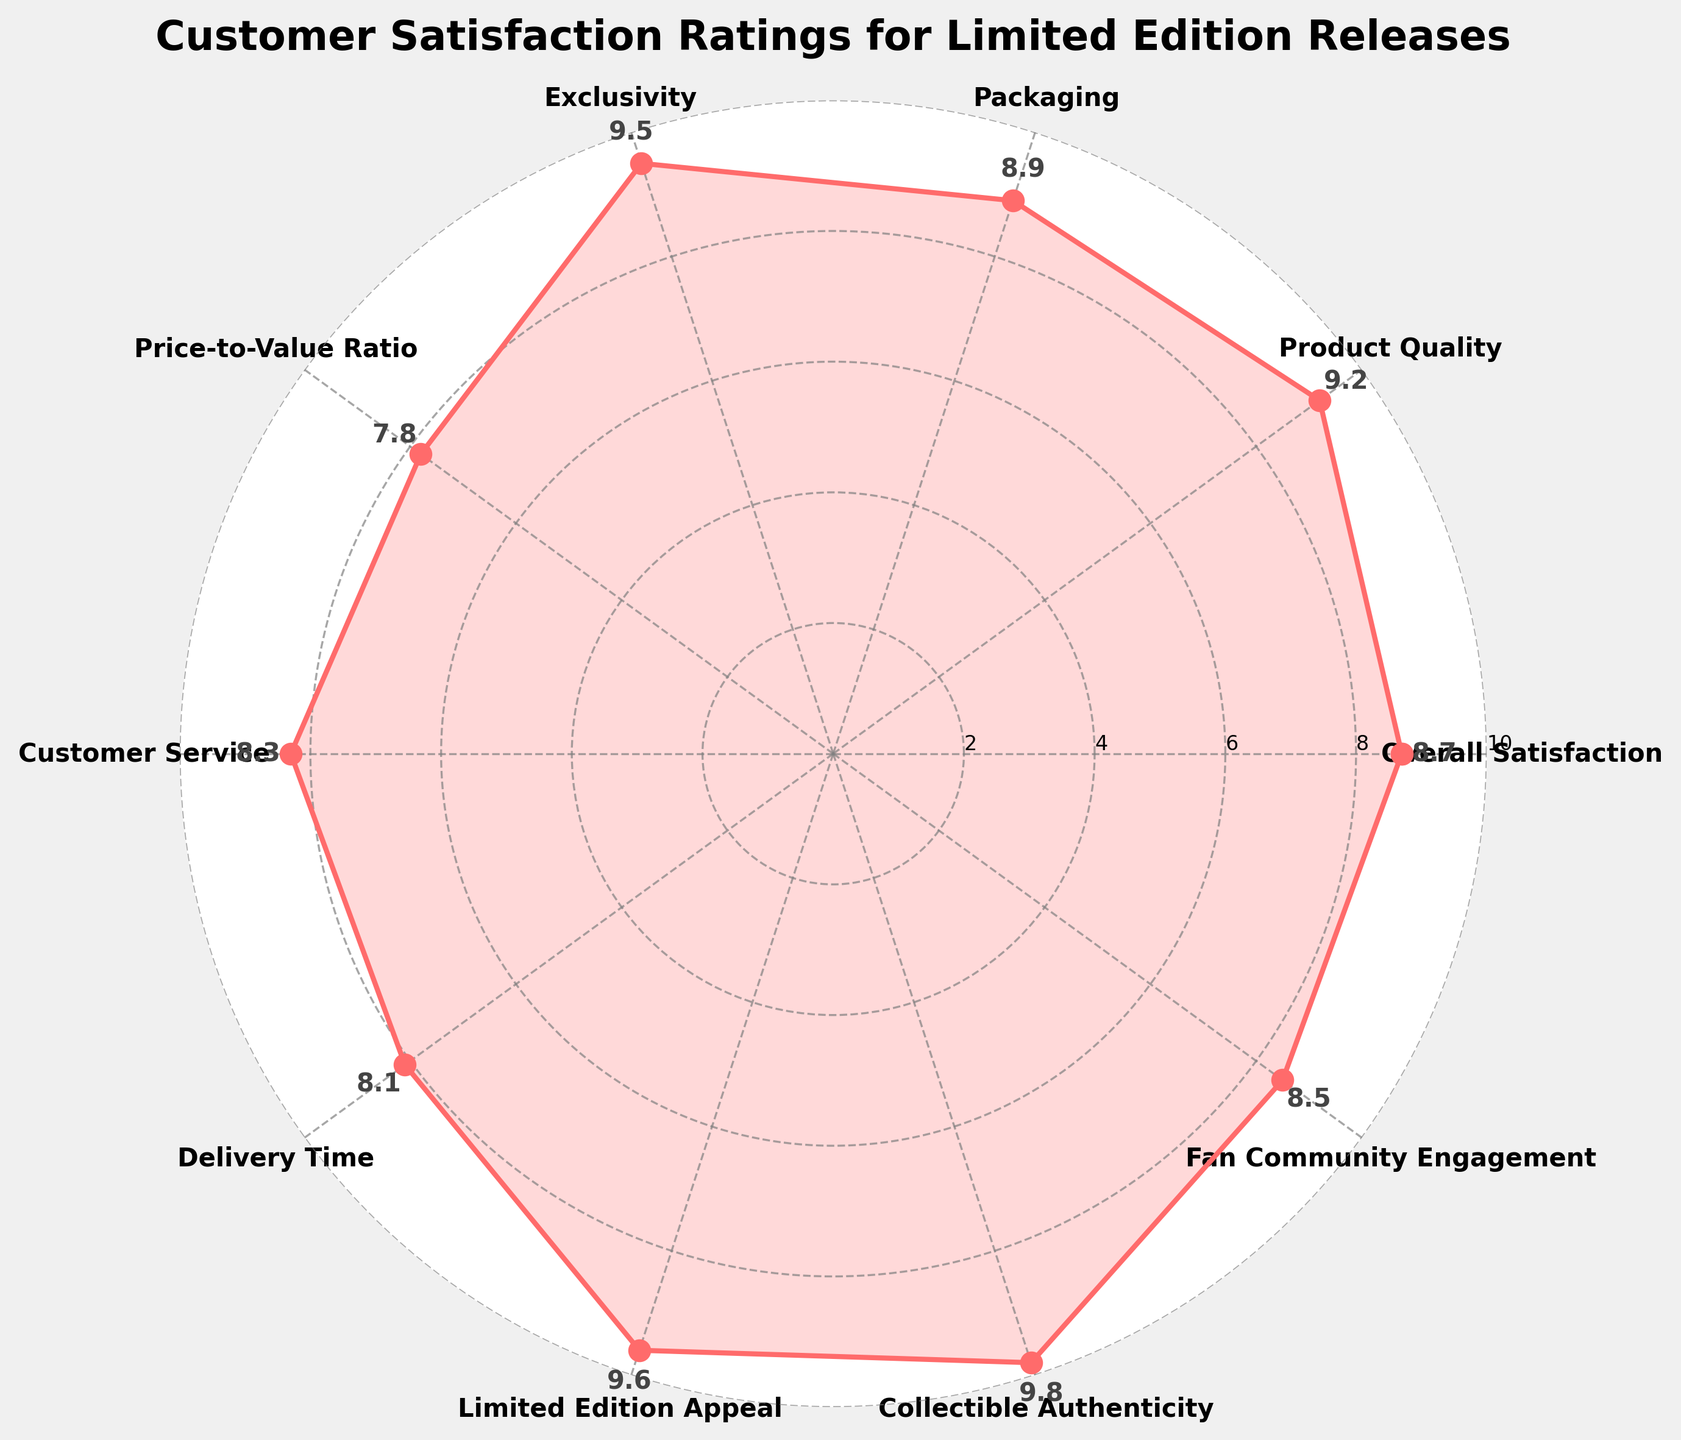What's the highest satisfaction rating shown in the figure? Identify the highest value among the ratings. The highest rating in the figure is 9.8 for "Collectible Authenticity".
Answer: 9.8 Which category has the lowest satisfaction rating? Compare all the satisfaction ratings and identify the category with the lowest value. "Price-to-Value Ratio" is the lowest with a rating of 7.8.
Answer: Price-to-Value Ratio What is the overall title of the figure? The title is given at the top of the figure, which summarizes the chart's content. The title is "Customer Satisfaction Ratings for Limited Edition Releases".
Answer: Customer Satisfaction Ratings for Limited Edition Releases How many categories are rated in the figure? Count the number of distinct points or categories along the polar plot. There are 10 categories rated.
Answer: 10 Which categories have ratings above 9? Examine the figure and list all categories with values above 9. These categories are "Product Quality", "Exclusivity", "Limited Edition Appeal", and "Collectible Authenticity".
Answer: Product Quality, Exclusivity, Limited Edition Appeal, Collectible Authenticity What is the average rating for all categories? Calculate the sum of all ratings and divide by the number of categories. Sum = 8.7 + 9.2 + 8.9 + 9.5 + 7.8 + 8.3 + 8.1 + 9.6 + 9.8 + 8.5, which is 88.4. Average = 88.4 / 10 = 8.84
Answer: 8.84 Is the satisfaction rating for "Delivery Time" above or below 9? Directly check the value next to "Delivery Time". The rating is 8.1, which is below 9.
Answer: Below How many categories have a rating below the average rating of all categories? First, find the average rating for all categories, which is 8.84. Then, count how many categories have a rating below 8.84. Those are "Overall Satisfaction", "Packaging", "Price-to-Value Ratio", "Customer Service", "Delivery Time", and "Fan Community Engagement", totaling 6 categories.
Answer: 6 What is the difference between the highest and lowest satisfaction ratings? Subtract the lowest rating (7.8 for "Price-to-Value Ratio") from the highest rating (9.8 for "Collectible Authenticity"). The difference is 9.8 - 7.8 = 2.0
Answer: 2.0 Which satisfaction rating is closest to 8.5? Identify the category with the rating closest to 8.5 by comparing the values. "Fan Community Engagement" has a satisfaction rating of 8.5, which matches exactly.
Answer: Fan Community Engagement 